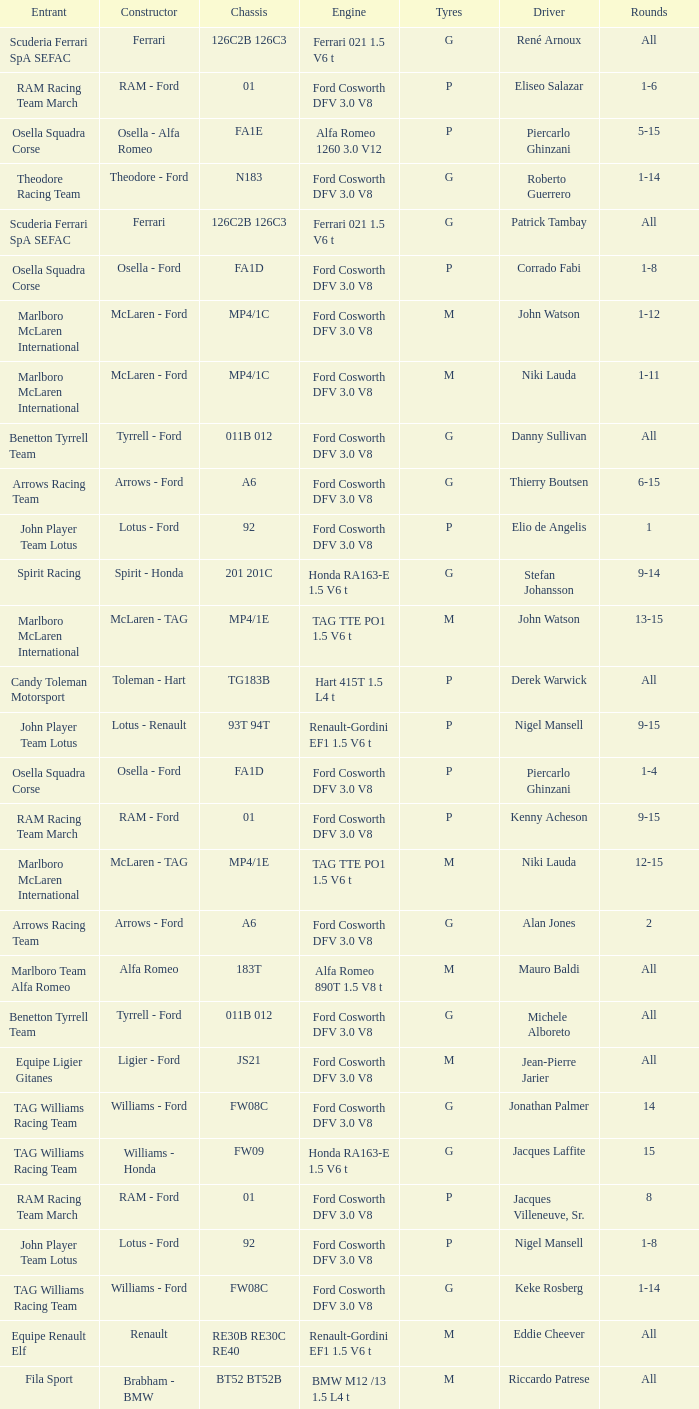Who is the Constructor for driver Piercarlo Ghinzani and a Ford cosworth dfv 3.0 v8 engine? Osella - Ford. 